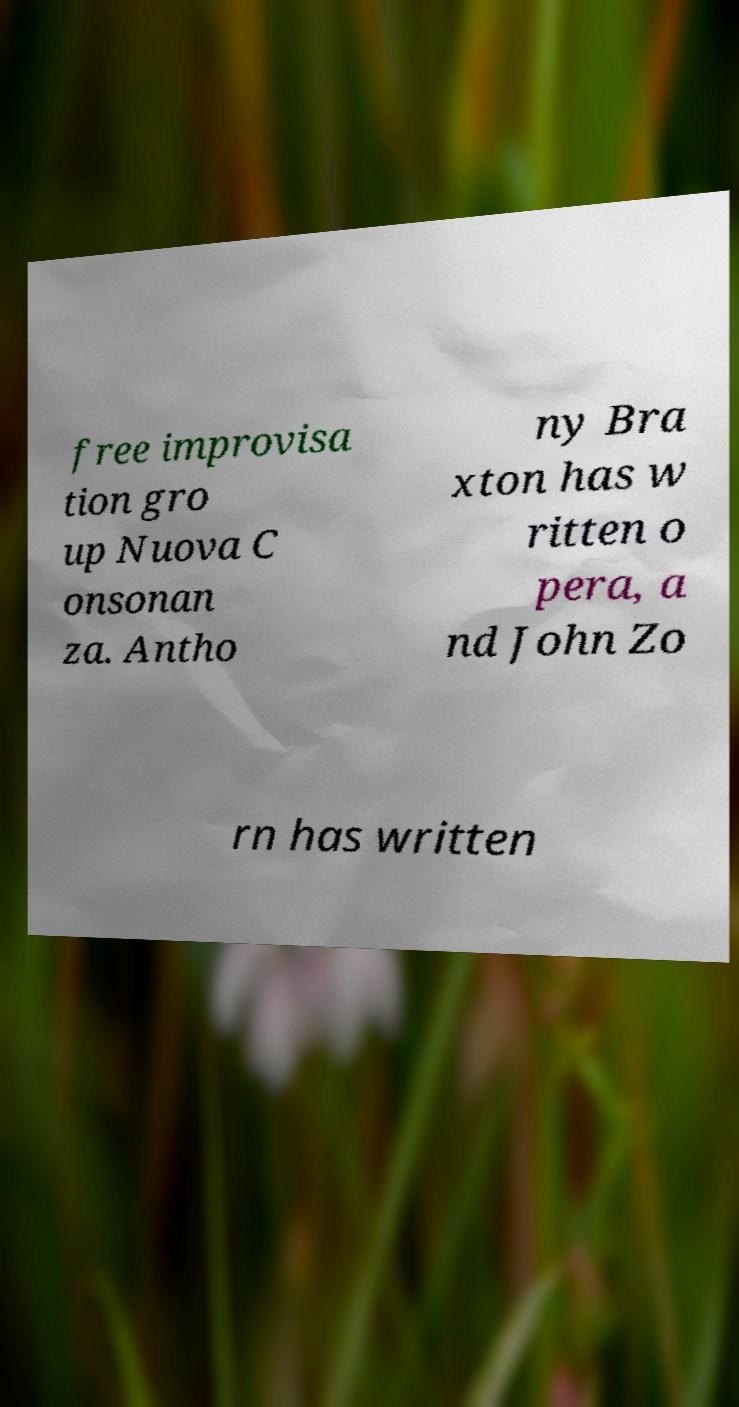What messages or text are displayed in this image? I need them in a readable, typed format. free improvisa tion gro up Nuova C onsonan za. Antho ny Bra xton has w ritten o pera, a nd John Zo rn has written 